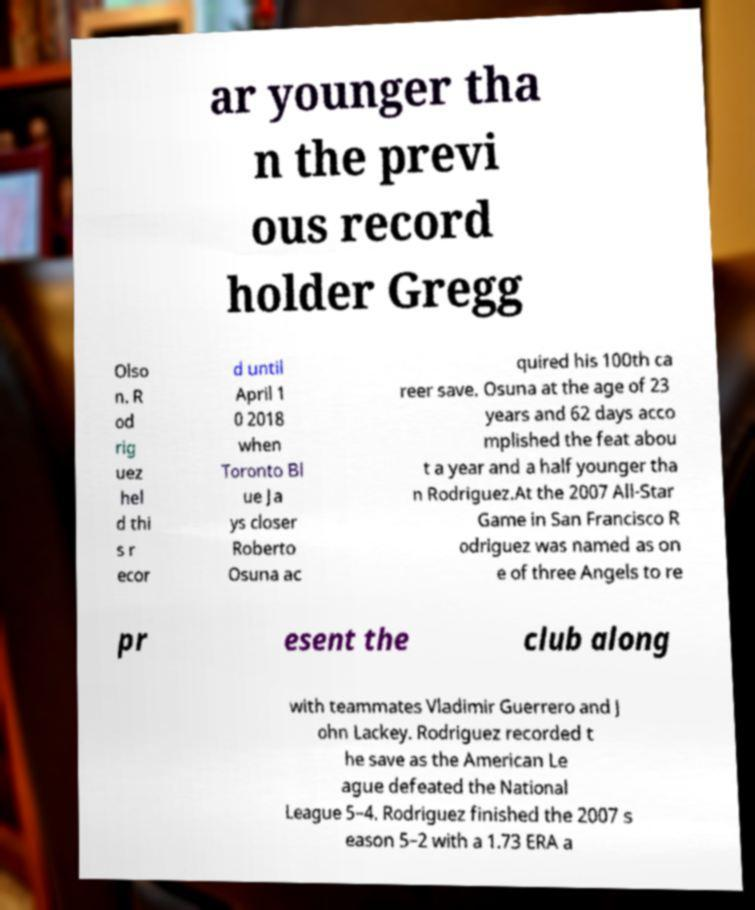I need the written content from this picture converted into text. Can you do that? ar younger tha n the previ ous record holder Gregg Olso n. R od rig uez hel d thi s r ecor d until April 1 0 2018 when Toronto Bl ue Ja ys closer Roberto Osuna ac quired his 100th ca reer save. Osuna at the age of 23 years and 62 days acco mplished the feat abou t a year and a half younger tha n Rodriguez.At the 2007 All-Star Game in San Francisco R odriguez was named as on e of three Angels to re pr esent the club along with teammates Vladimir Guerrero and J ohn Lackey. Rodriguez recorded t he save as the American Le ague defeated the National League 5–4. Rodriguez finished the 2007 s eason 5–2 with a 1.73 ERA a 